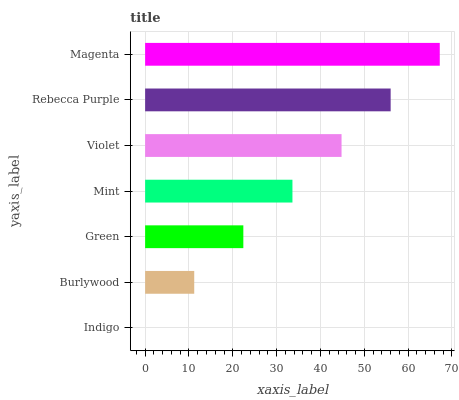Is Indigo the minimum?
Answer yes or no. Yes. Is Magenta the maximum?
Answer yes or no. Yes. Is Burlywood the minimum?
Answer yes or no. No. Is Burlywood the maximum?
Answer yes or no. No. Is Burlywood greater than Indigo?
Answer yes or no. Yes. Is Indigo less than Burlywood?
Answer yes or no. Yes. Is Indigo greater than Burlywood?
Answer yes or no. No. Is Burlywood less than Indigo?
Answer yes or no. No. Is Mint the high median?
Answer yes or no. Yes. Is Mint the low median?
Answer yes or no. Yes. Is Magenta the high median?
Answer yes or no. No. Is Magenta the low median?
Answer yes or no. No. 